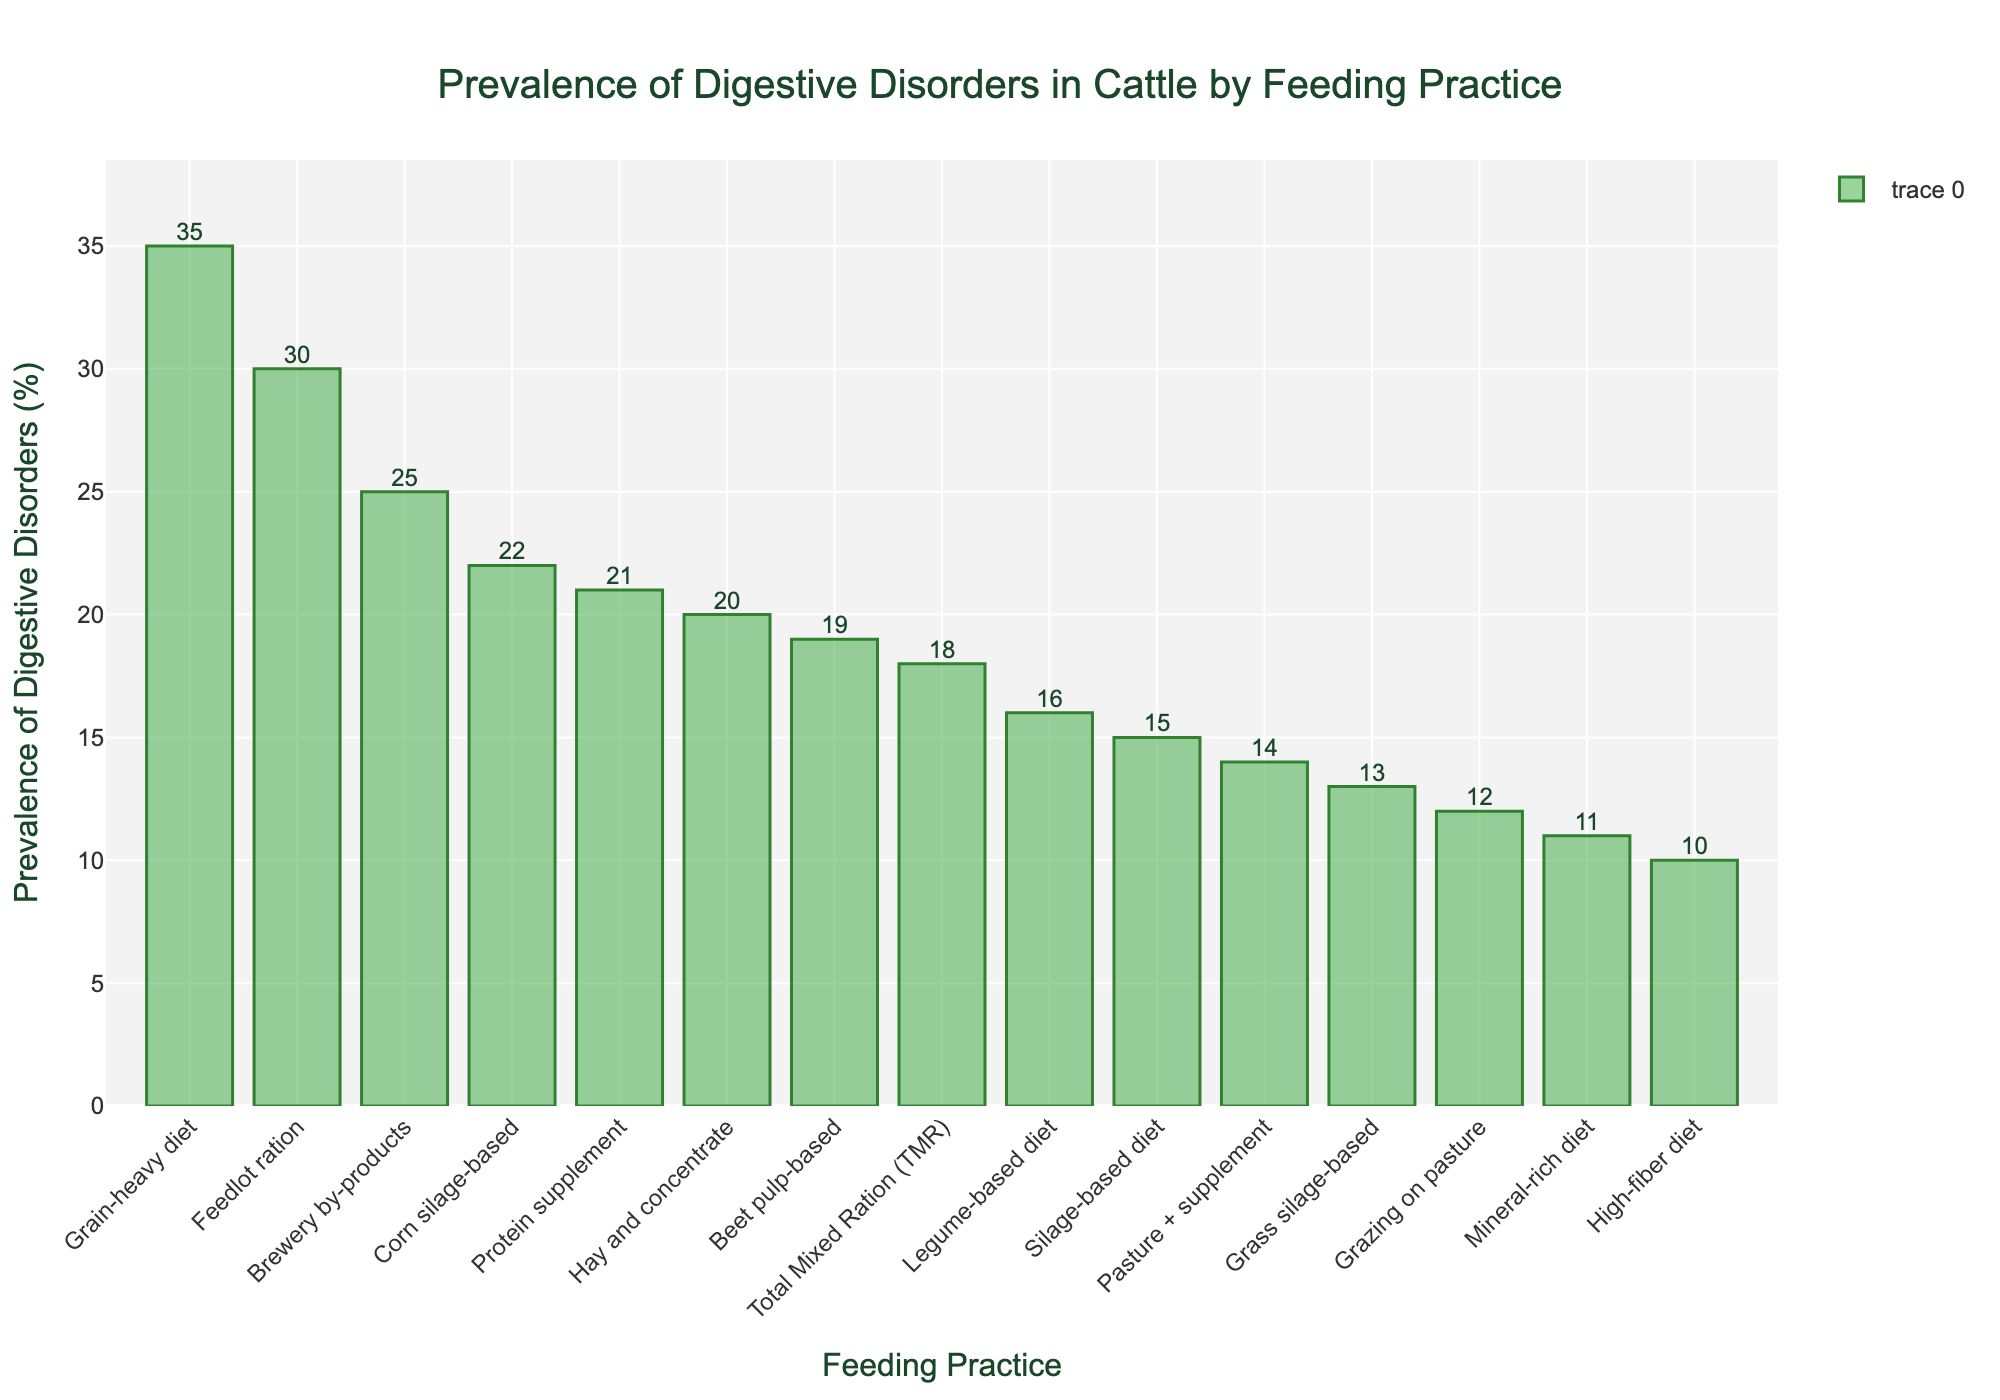Which feeding practice has the highest prevalence of digestive disorders? The feeding practice with the highest prevalence can be identified by looking for the tallest bar in the chart. The "Grain-heavy diet" has the highest bar, indicating it has the highest prevalence.
Answer: Grain-heavy diet Which feeding practice has the lowest prevalence of digestive disorders? The feeding practice with the lowest prevalence can be identified by looking for the shortest bar in the chart. The "High-fiber diet" has the shortest bar, indicating it has the lowest prevalence.
Answer: High-fiber diet What is the difference in prevalence of digestive disorders between "Grain-heavy diet" and "Feedlot ration"? The prevalence of digestive disorders for the "Grain-heavy diet" is 35%, and for the "Feedlot ration," it is 30%. The difference can be calculated by subtracting the lower percentage from the higher percentage.
Answer: 5% Which feeding practice has a higher prevalence of digestive disorders, "Hay and concentrate" or "Silage-based diet"? Compare the heights of the bars for "Hay and concentrate" (20%) and "Silage-based diet" (15%). The bar for "Hay and concentrate" is taller.
Answer: Hay and concentrate How many feeding practices have a prevalence of digestive disorders above 20%? Count the bars that exceed the 20% mark. These are "Grain-heavy diet" (35%), "Feedlot ration" (30%), "Corn silage-based" (22%), and "Brewery by-products" (25%), totaling 4.
Answer: 4 What is the average prevalence of digestive disorders for the feeding practices: "Grazing on pasture," "Total Mixed Ration," and "Hay and concentrate"? Add the prevalence percentages for these three feeding practices: 12% (Grazing on pasture), 18% (Total Mixed Ration), and 20% (Hay and concentrate). Sum = 50%. Divide by 3 to get the average. 50/3 = 16.67%
Answer: 16.67% Which feeding practice has a prevalence closest to 15%? By examining the chart, the feeding practice "Silage-based diet" has a prevalence of 15%, which matches exactly.
Answer: Silage-based diet Which is greater, the prevalence of digestive disorders in the "Protein supplement" or the "Beet pulp-based" feeding practice? Compare the prevalence percentages: "Protein supplement" is 21%, while "Beet pulp-based" is 19%. "Protein supplement" has a greater prevalence.
Answer: Protein supplement 